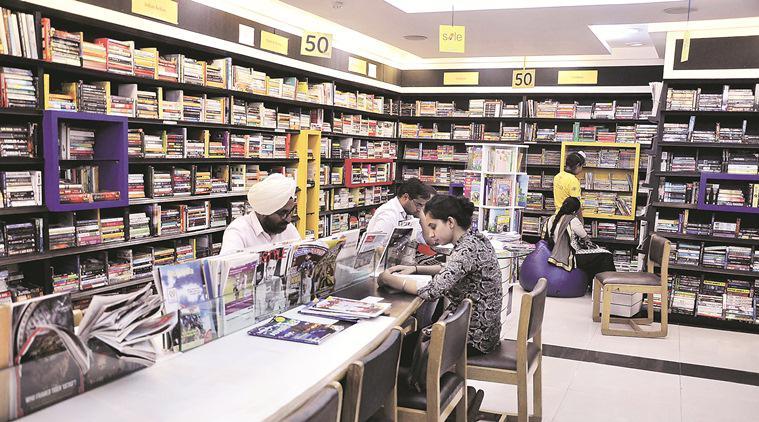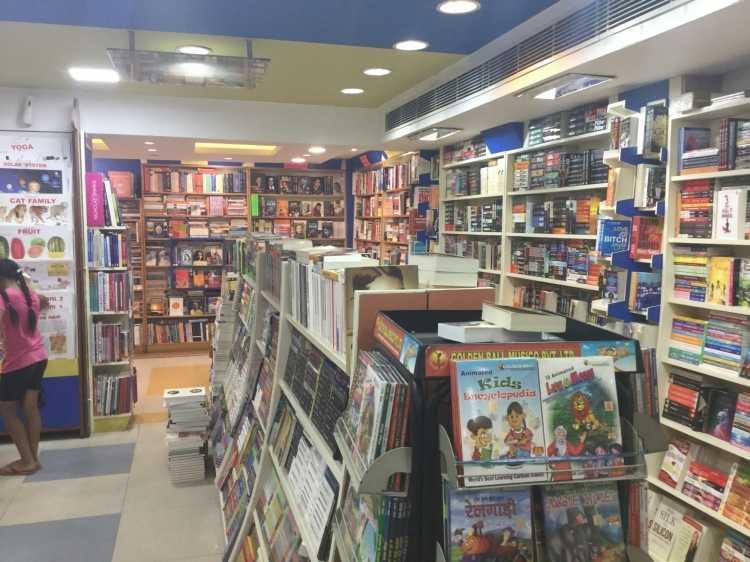The first image is the image on the left, the second image is the image on the right. Assess this claim about the two images: "Exactly one person, a standing woman, can be seen inside of a shop lined with bookshelves.". Correct or not? Answer yes or no. Yes. The first image is the image on the left, the second image is the image on the right. Assess this claim about the two images: "People are standing in a bookstore.". Correct or not? Answer yes or no. Yes. 